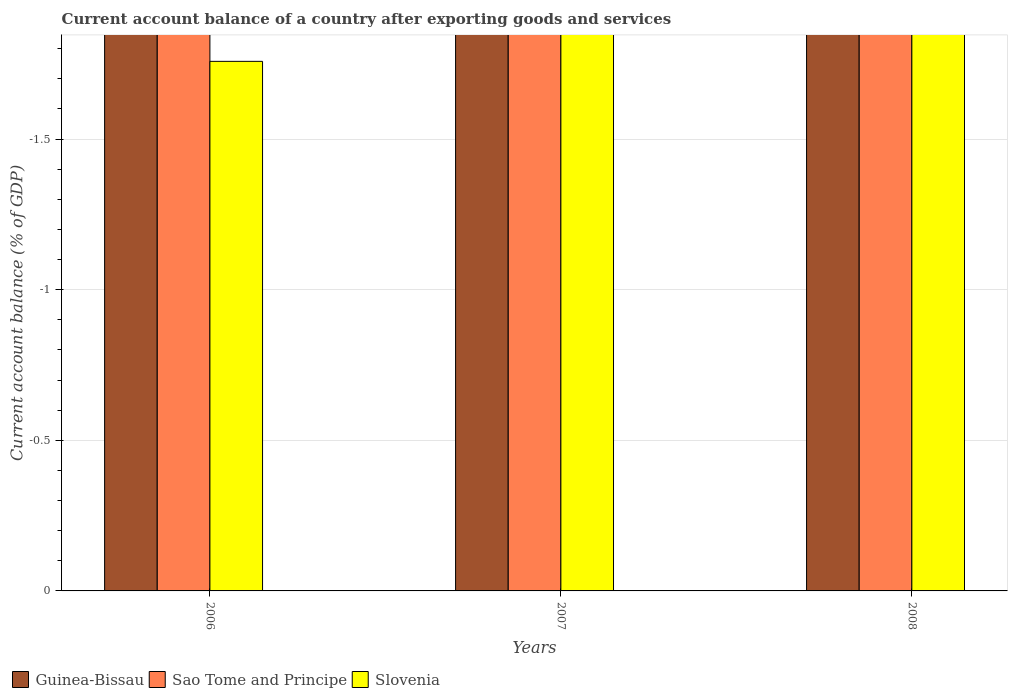How many different coloured bars are there?
Provide a succinct answer. 0. Are the number of bars on each tick of the X-axis equal?
Make the answer very short. Yes. How many bars are there on the 3rd tick from the left?
Offer a very short reply. 0. In how many cases, is the number of bars for a given year not equal to the number of legend labels?
Give a very brief answer. 3. What is the total account balance in Guinea-Bissau in the graph?
Offer a very short reply. 0. What is the average account balance in Slovenia per year?
Your answer should be very brief. 0. In how many years, is the account balance in Sao Tome and Principe greater than -1.8 %?
Ensure brevity in your answer.  0. In how many years, is the account balance in Slovenia greater than the average account balance in Slovenia taken over all years?
Offer a very short reply. 0. How many bars are there?
Your answer should be compact. 0. What is the difference between two consecutive major ticks on the Y-axis?
Ensure brevity in your answer.  0.5. Does the graph contain grids?
Give a very brief answer. Yes. How are the legend labels stacked?
Your answer should be very brief. Horizontal. What is the title of the graph?
Your answer should be very brief. Current account balance of a country after exporting goods and services. Does "Greece" appear as one of the legend labels in the graph?
Provide a succinct answer. No. What is the label or title of the X-axis?
Offer a terse response. Years. What is the label or title of the Y-axis?
Your answer should be very brief. Current account balance (% of GDP). What is the Current account balance (% of GDP) of Sao Tome and Principe in 2006?
Your answer should be compact. 0. What is the Current account balance (% of GDP) of Guinea-Bissau in 2007?
Provide a succinct answer. 0. What is the Current account balance (% of GDP) of Sao Tome and Principe in 2007?
Offer a very short reply. 0. What is the Current account balance (% of GDP) of Slovenia in 2007?
Offer a very short reply. 0. What is the Current account balance (% of GDP) of Slovenia in 2008?
Make the answer very short. 0. What is the total Current account balance (% of GDP) of Guinea-Bissau in the graph?
Offer a terse response. 0. What is the total Current account balance (% of GDP) of Slovenia in the graph?
Ensure brevity in your answer.  0. What is the average Current account balance (% of GDP) of Guinea-Bissau per year?
Your answer should be very brief. 0. What is the average Current account balance (% of GDP) in Slovenia per year?
Keep it short and to the point. 0. 